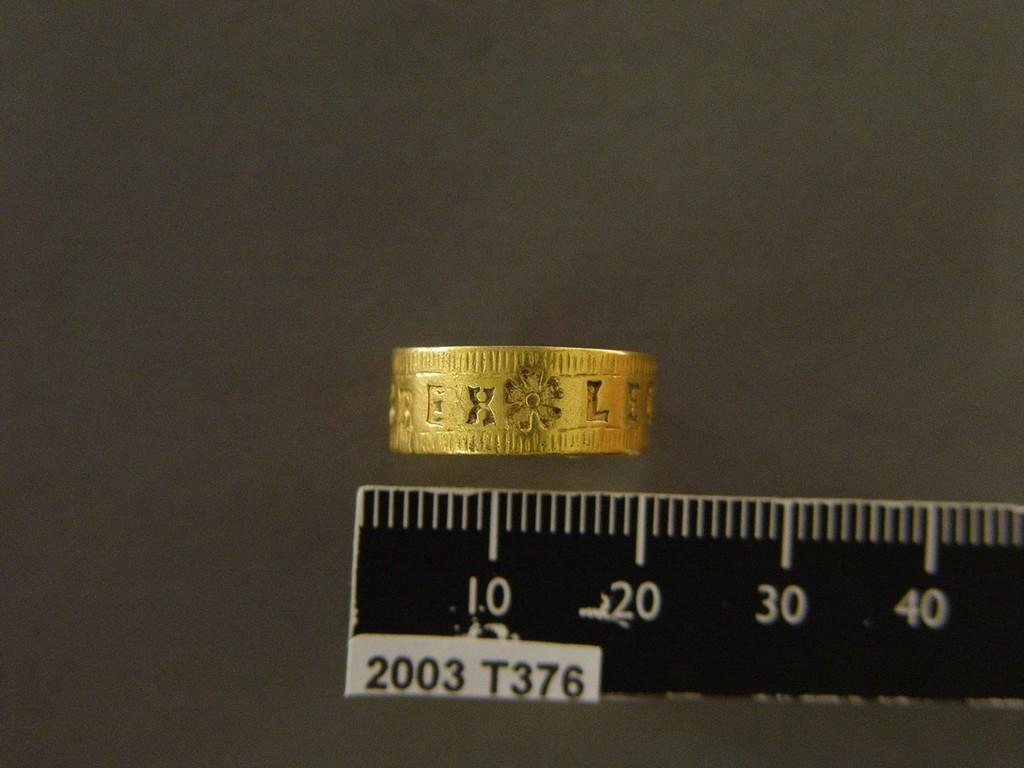<image>
Give a short and clear explanation of the subsequent image. A gold ring with the letters EXLE engraved on it is being measured. 